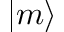<formula> <loc_0><loc_0><loc_500><loc_500>| m \rangle</formula> 